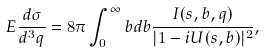<formula> <loc_0><loc_0><loc_500><loc_500>E \frac { d \sigma } { d ^ { 3 } q } = 8 \pi \int _ { 0 } ^ { \infty } b d b \frac { I ( s , b , q ) } { | 1 - i U ( s , b ) | ^ { 2 } } ,</formula> 